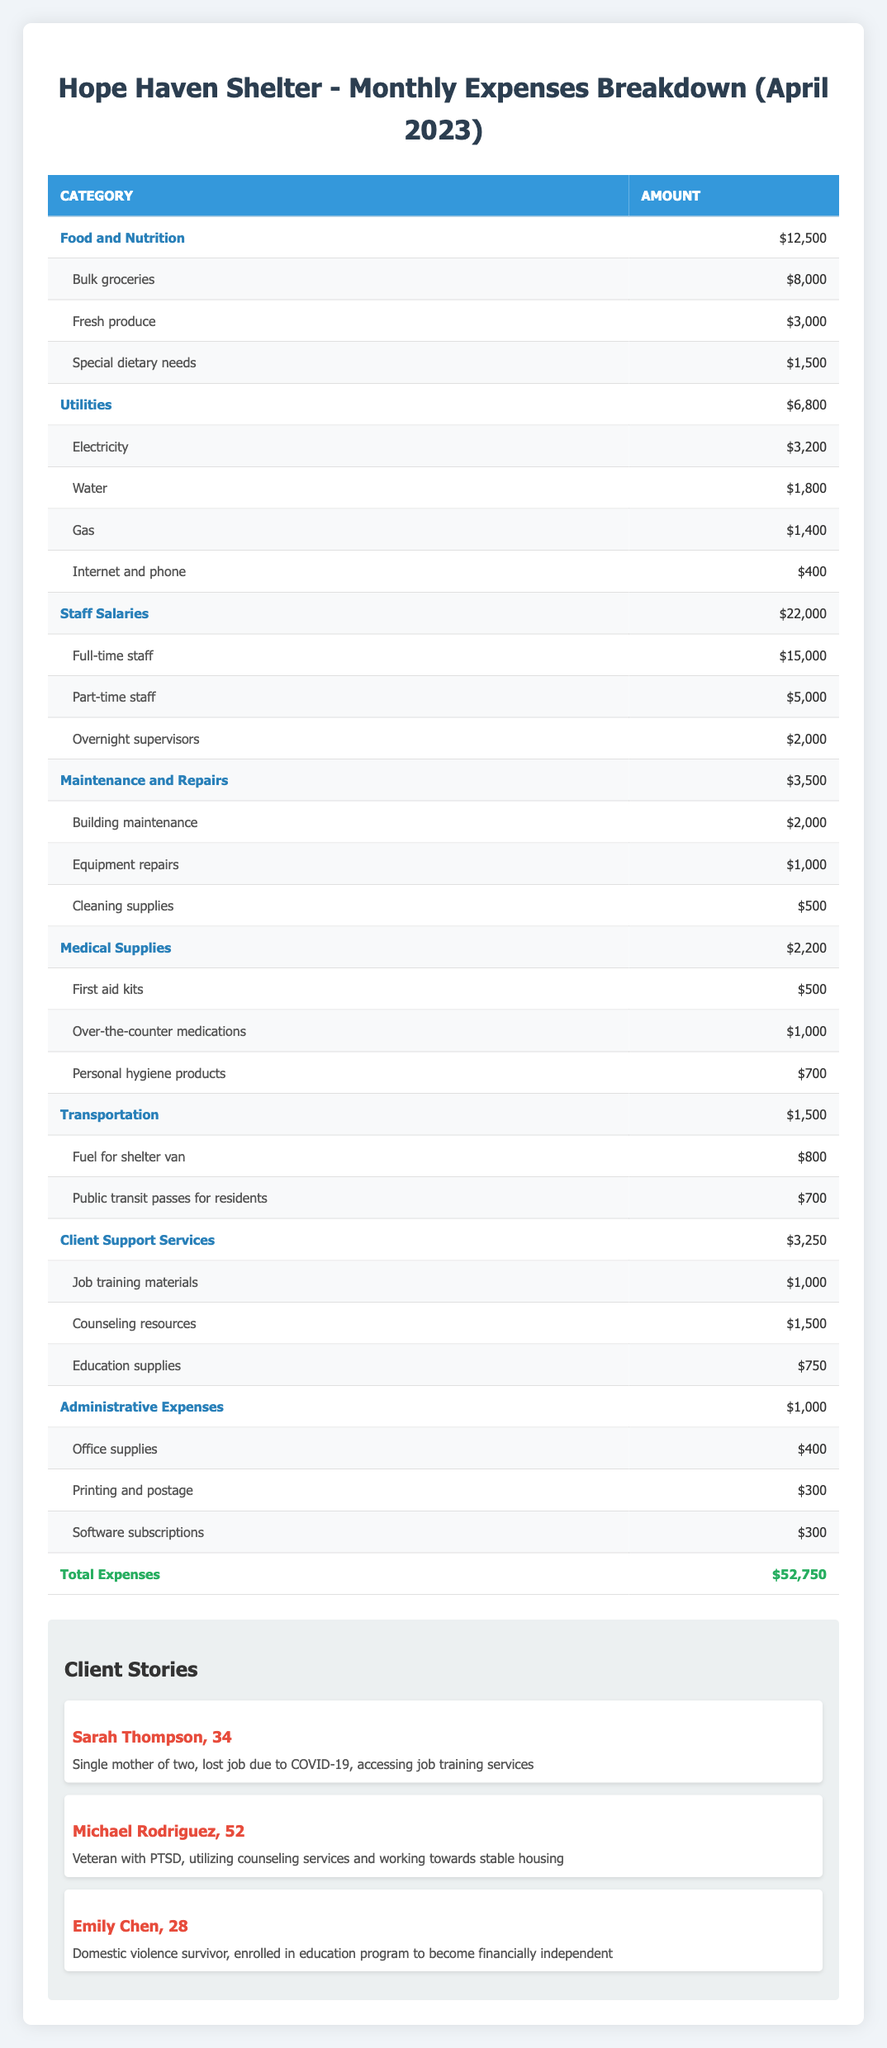What is the total amount spent on food and nutrition? The table shows that the food and nutrition category has an amount of $12,500.
Answer: $12,500 How much is spent on utilities? The utilities category indicates an expense amount of $6,800.
Answer: $6,800 What is the combined total for staff salaries and medical supplies? Staff salaries amount to $22,000, and medical supplies amount to $2,200. Adding these gives $22,000 + $2,200 = $24,200.
Answer: $24,200 Is the amount spent on maintenance and repairs greater than the amount spent on transportation? The maintenance and repairs category shows $3,500, while transportation expenses are $1,500. Since $3,500 is greater than $1,500, the answer is yes.
Answer: Yes What is the total amount allocated to client support services? The client support services category has an expense total of $3,250 according to the table.
Answer: $3,250 How much did the shelter spend on electricity compared to water? The table shows that electricity costs $3,200 and water costs $1,800. The difference is $3,200 - $1,800 = $1,400 more was spent on electricity.
Answer: $1,400 What percentage of the total expenses was used for staff salaries? Total expenses are $52,750, and staff salaries are $22,000. To find the percentage: (22,000 / 52,750) * 100 = 41.68%.
Answer: 41.68% Which category has the highest expense? The staff salaries category shows an expense of $22,000, which is the highest compared to other categories listed in the table.
Answer: Staff Salaries How much is spent on job training materials, and how does it compare to the total for medical supplies? Job training materials cost $1,000, and total medical supplies cost $2,200. The difference is $2,200 - $1,000 = $1,200, indicating that medical supplies are $1,200 more than job training materials.
Answer: $1,200 Was the total expenditure for utilities lower than the combined amount spent on medical supplies and transportation? The total for utilities is $6,800. Medical supplies are $2,200, and transportation is $1,500. Combined, they equal $2,200 + $1,500 = $3,700, which is less than $6,800, so the answer is no.
Answer: No 